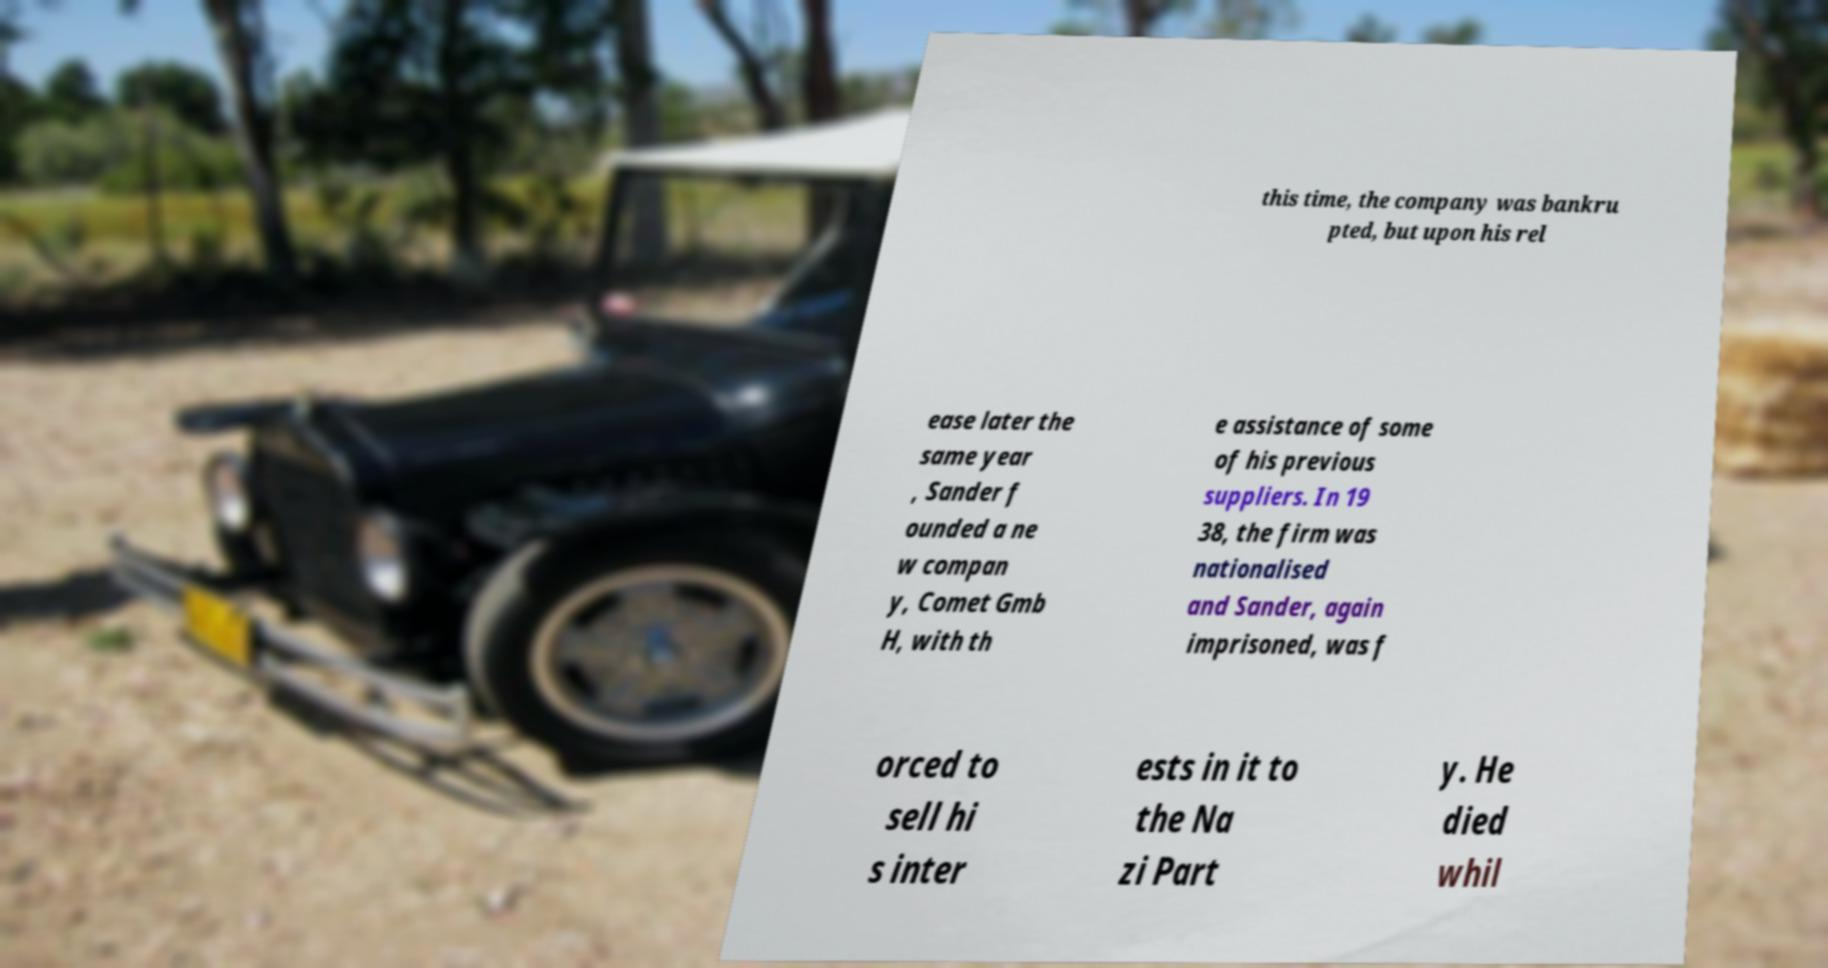Could you assist in decoding the text presented in this image and type it out clearly? this time, the company was bankru pted, but upon his rel ease later the same year , Sander f ounded a ne w compan y, Comet Gmb H, with th e assistance of some of his previous suppliers. In 19 38, the firm was nationalised and Sander, again imprisoned, was f orced to sell hi s inter ests in it to the Na zi Part y. He died whil 